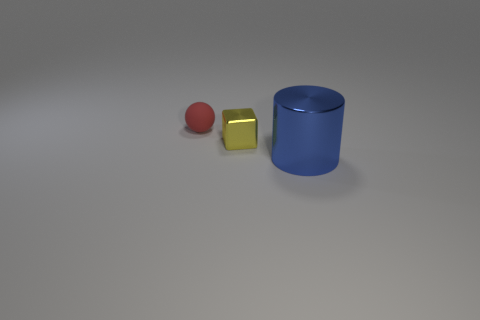Add 3 tiny red things. How many objects exist? 6 Subtract all cylinders. How many objects are left? 2 Subtract all blue metallic cylinders. Subtract all big blue shiny things. How many objects are left? 1 Add 2 blue objects. How many blue objects are left? 3 Add 1 small cyan metal balls. How many small cyan metal balls exist? 1 Subtract 0 yellow balls. How many objects are left? 3 